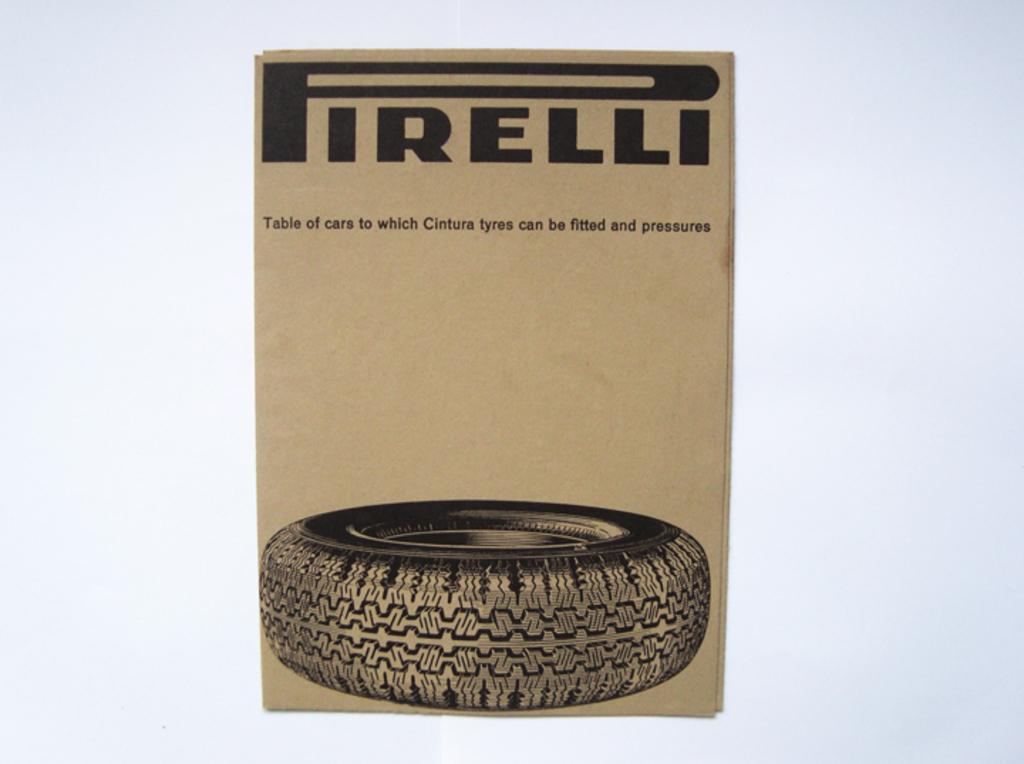Please provide a concise description of this image. In this image there is a cardboard, there is a tyre, text on the cardboard. 